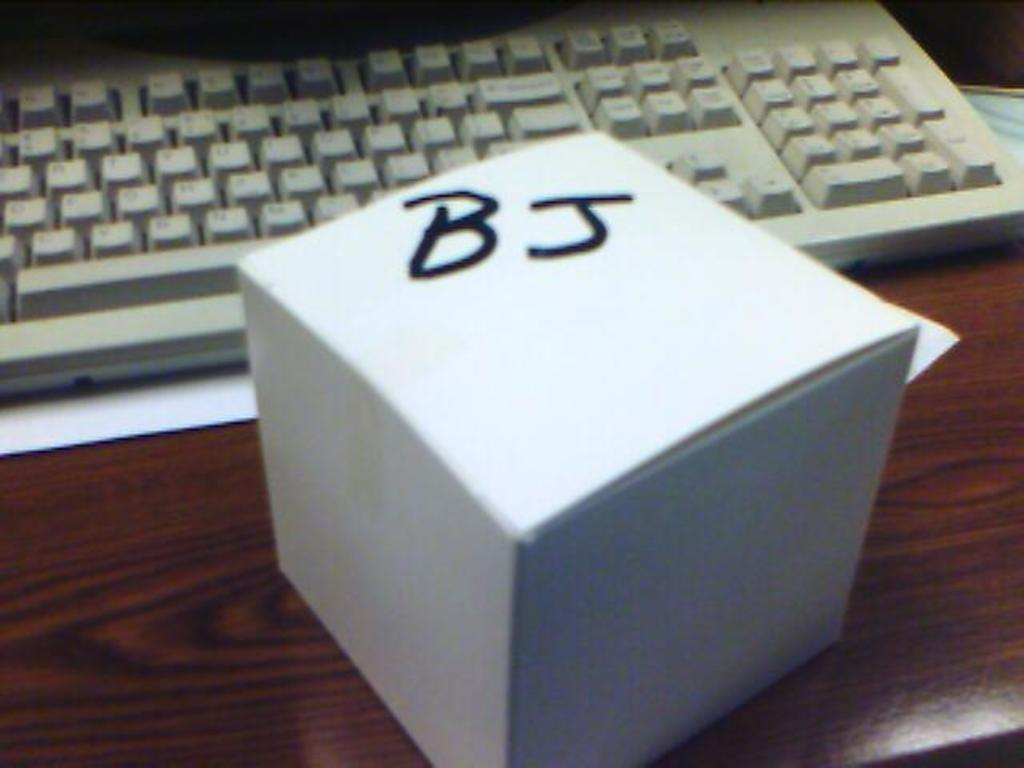Provide a one-sentence caption for the provided image. A white box with the letters BJ written on it sitting on a desk. 